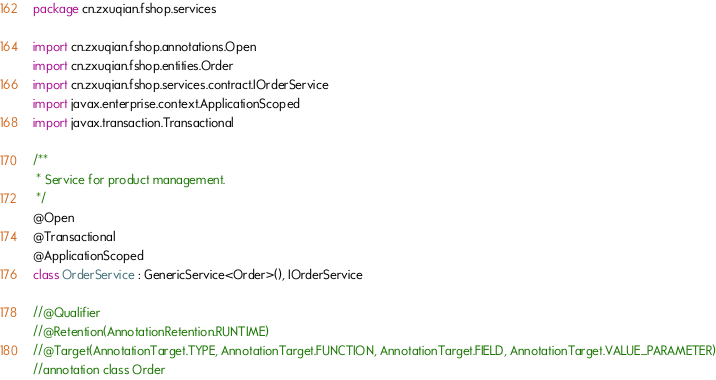Convert code to text. <code><loc_0><loc_0><loc_500><loc_500><_Kotlin_>package cn.zxuqian.fshop.services

import cn.zxuqian.fshop.annotations.Open
import cn.zxuqian.fshop.entities.Order
import cn.zxuqian.fshop.services.contract.IOrderService
import javax.enterprise.context.ApplicationScoped
import javax.transaction.Transactional

/**
 * Service for product management.
 */
@Open
@Transactional
@ApplicationScoped
class OrderService : GenericService<Order>(), IOrderService

//@Qualifier
//@Retention(AnnotationRetention.RUNTIME)
//@Target(AnnotationTarget.TYPE, AnnotationTarget.FUNCTION, AnnotationTarget.FIELD, AnnotationTarget.VALUE_PARAMETER)
//annotation class Order</code> 